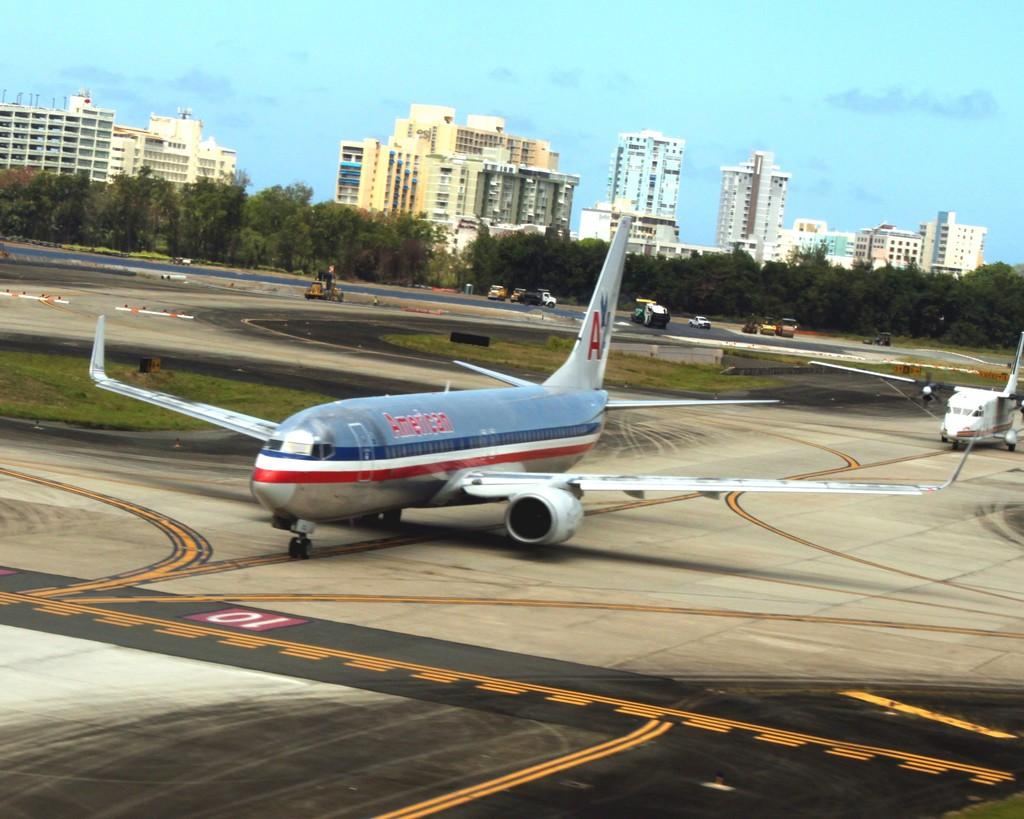What is the main subject of the image? The main subject of the image is aeroplanes. What can be seen in the background of the image? In the background, there are vehicles on the runway, buildings, trees, and the sky. Can you describe the setting of the image? The image appears to be set at an airport, with aeroplanes on the runway and buildings in the background. What type of mask is being worn by the aeroplanes in the image? There are no masks present on the aeroplanes in the image. 